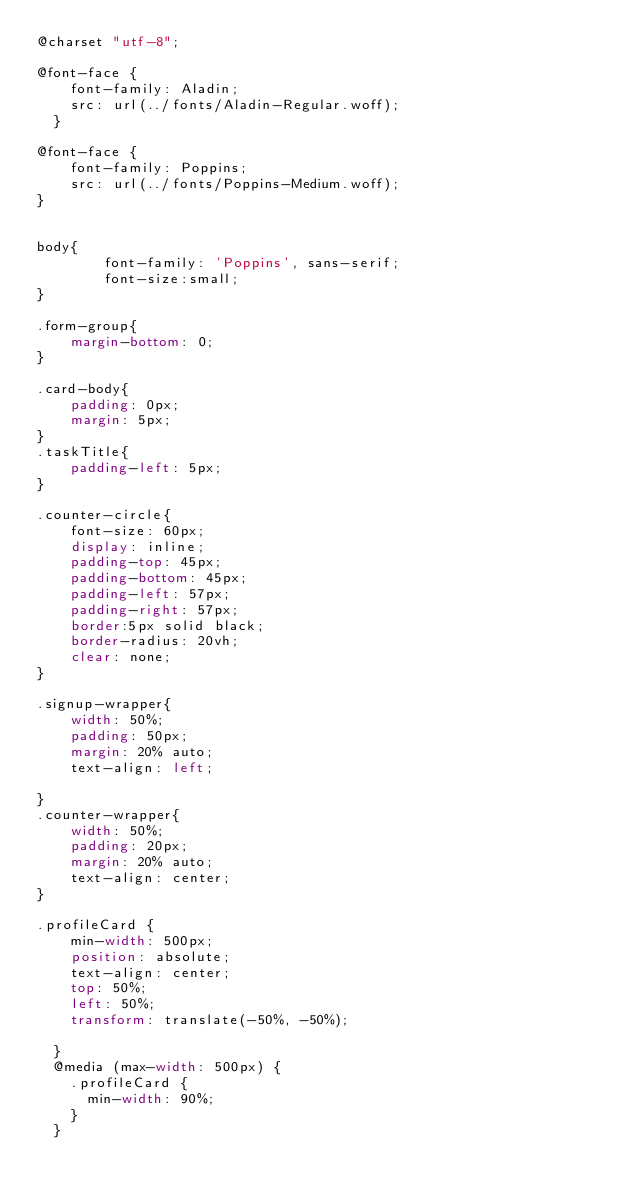Convert code to text. <code><loc_0><loc_0><loc_500><loc_500><_CSS_>@charset "utf-8";

@font-face {
	font-family: Aladin;
	src: url(../fonts/Aladin-Regular.woff);
  }

@font-face {
	font-family: Poppins;
	src: url(../fonts/Poppins-Medium.woff);
}


body{
	    font-family: 'Poppins', sans-serif;
		font-size:small;
}

.form-group{
	margin-bottom: 0;
}

.card-body{
	padding: 0px;
	margin: 5px;
}
.taskTitle{
	padding-left: 5px;
}

.counter-circle{
	font-size: 60px;
	display: inline;
	padding-top: 45px;
	padding-bottom: 45px;
	padding-left: 57px;
	padding-right: 57px;
	border:5px solid black; 
	border-radius: 20vh;
	clear: none;
}

.signup-wrapper{
	width: 50%;
    padding: 50px;
    margin: 20% auto;
    text-align: left;
  
}
.counter-wrapper{
	width: 50%;
    padding: 20px;
    margin: 20% auto;
    text-align: center;
}

.profileCard {
	min-width: 500px;
	position: absolute;
	text-align: center;
	top: 50%;
	left: 50%;
	transform: translate(-50%, -50%);
	
  }
  @media (max-width: 500px) {
	.profileCard {
	  min-width: 90%;
	}
  }</code> 